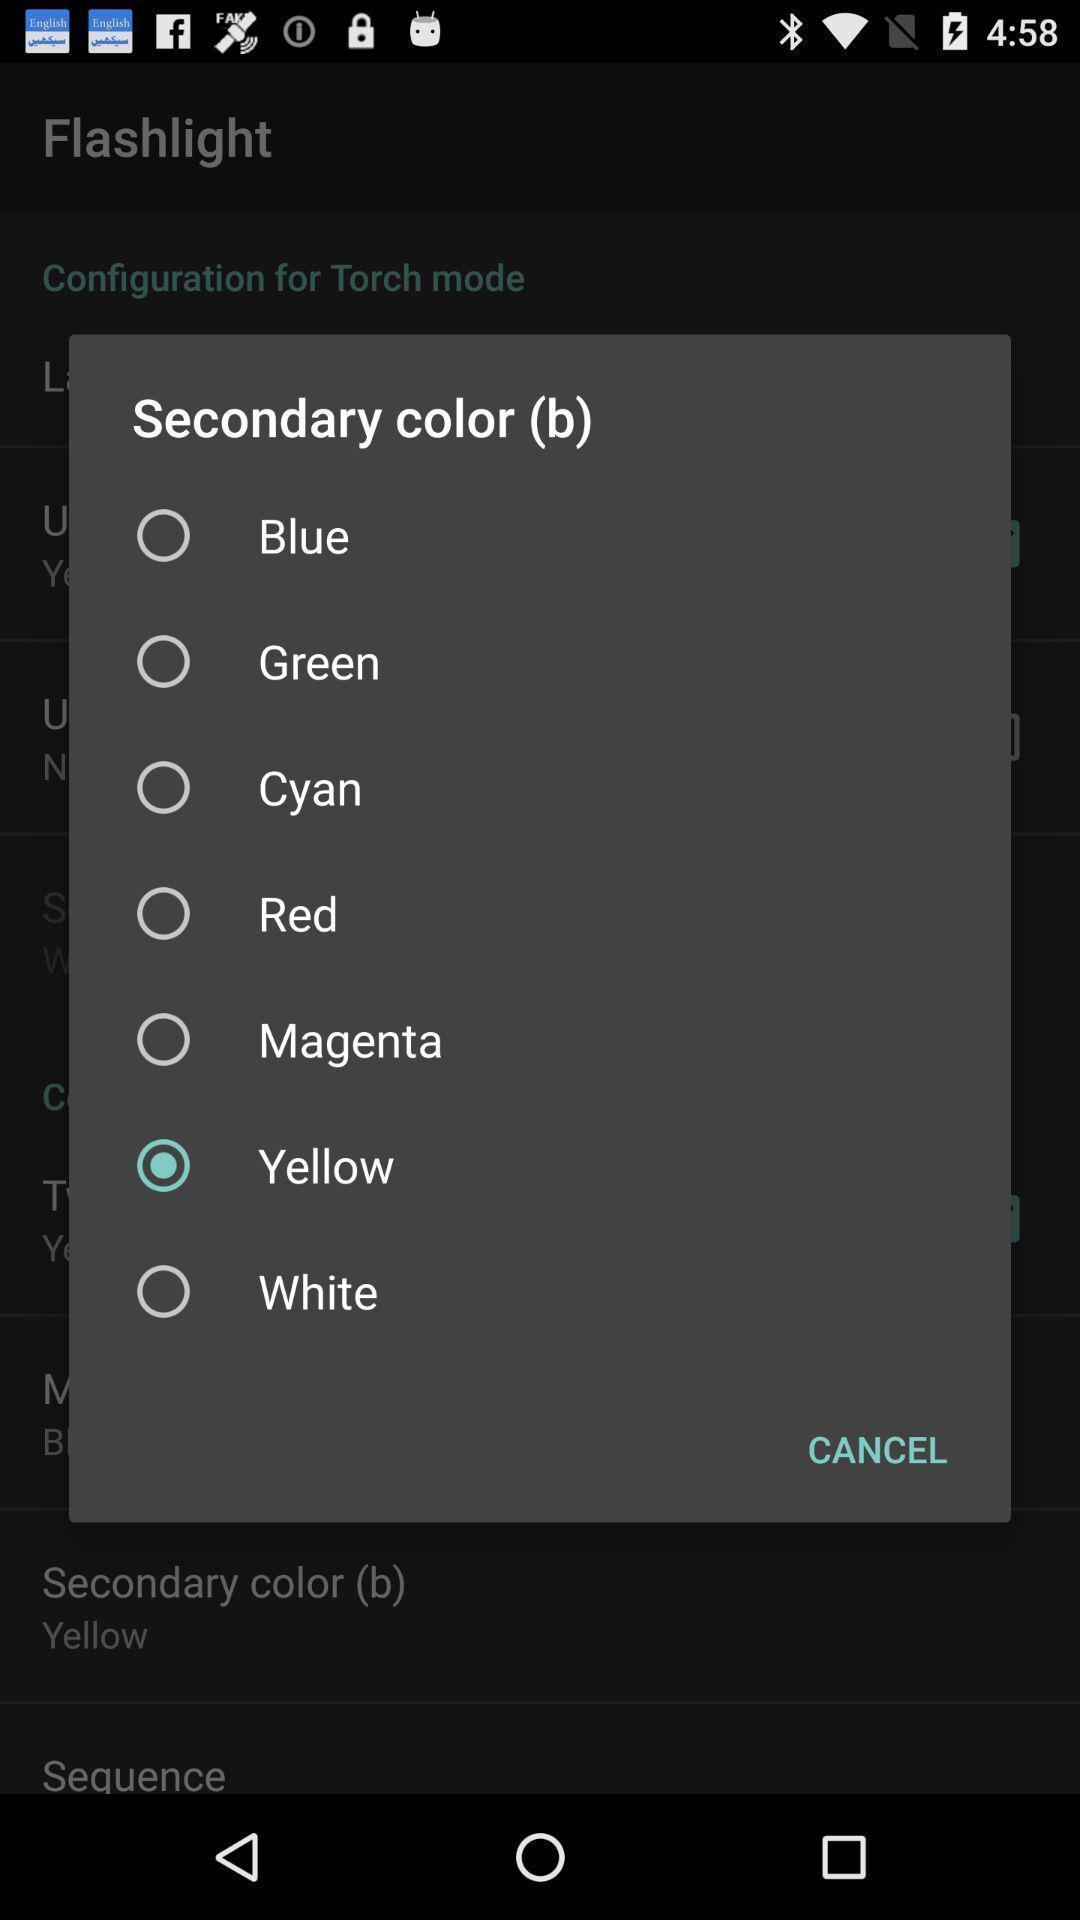Summarize the main components in this picture. Pop-up displaying the list of colors to select. 